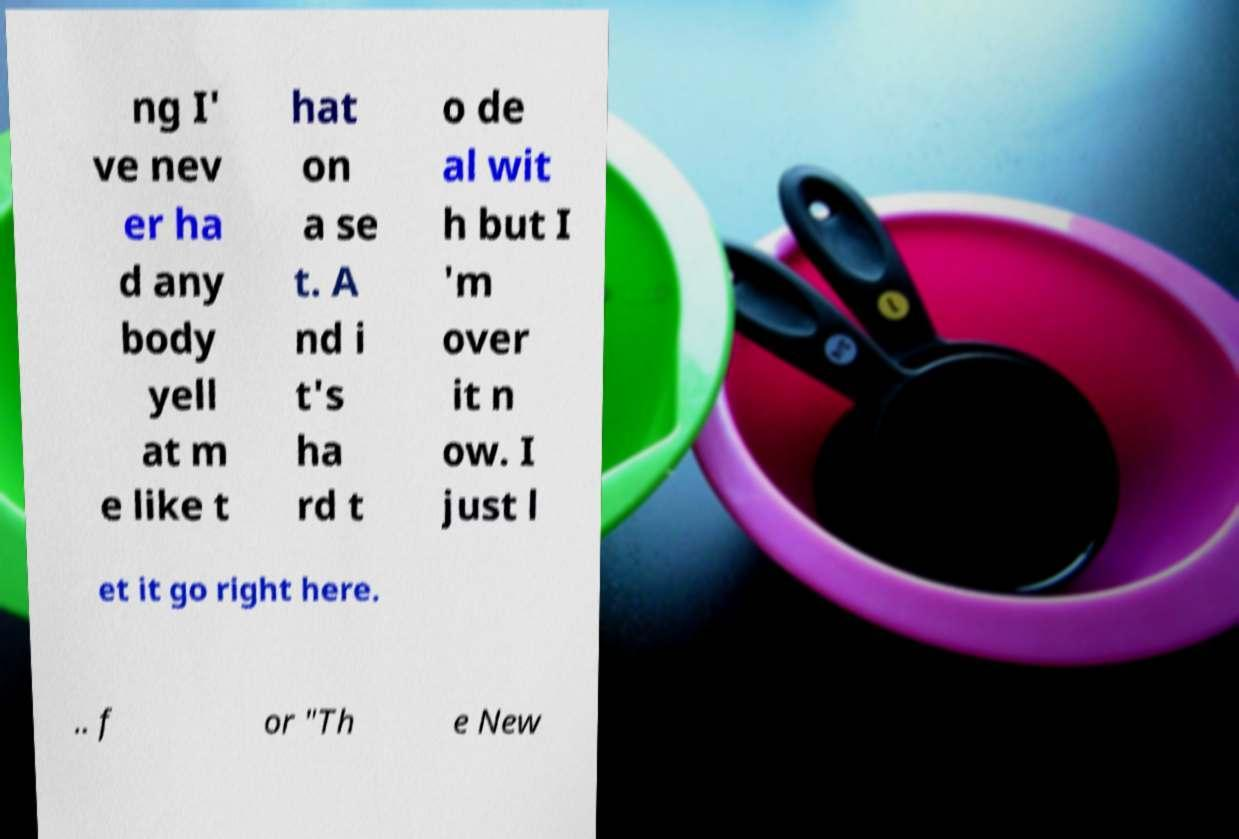Can you accurately transcribe the text from the provided image for me? ng I' ve nev er ha d any body yell at m e like t hat on a se t. A nd i t's ha rd t o de al wit h but I 'm over it n ow. I just l et it go right here. .. f or "Th e New 